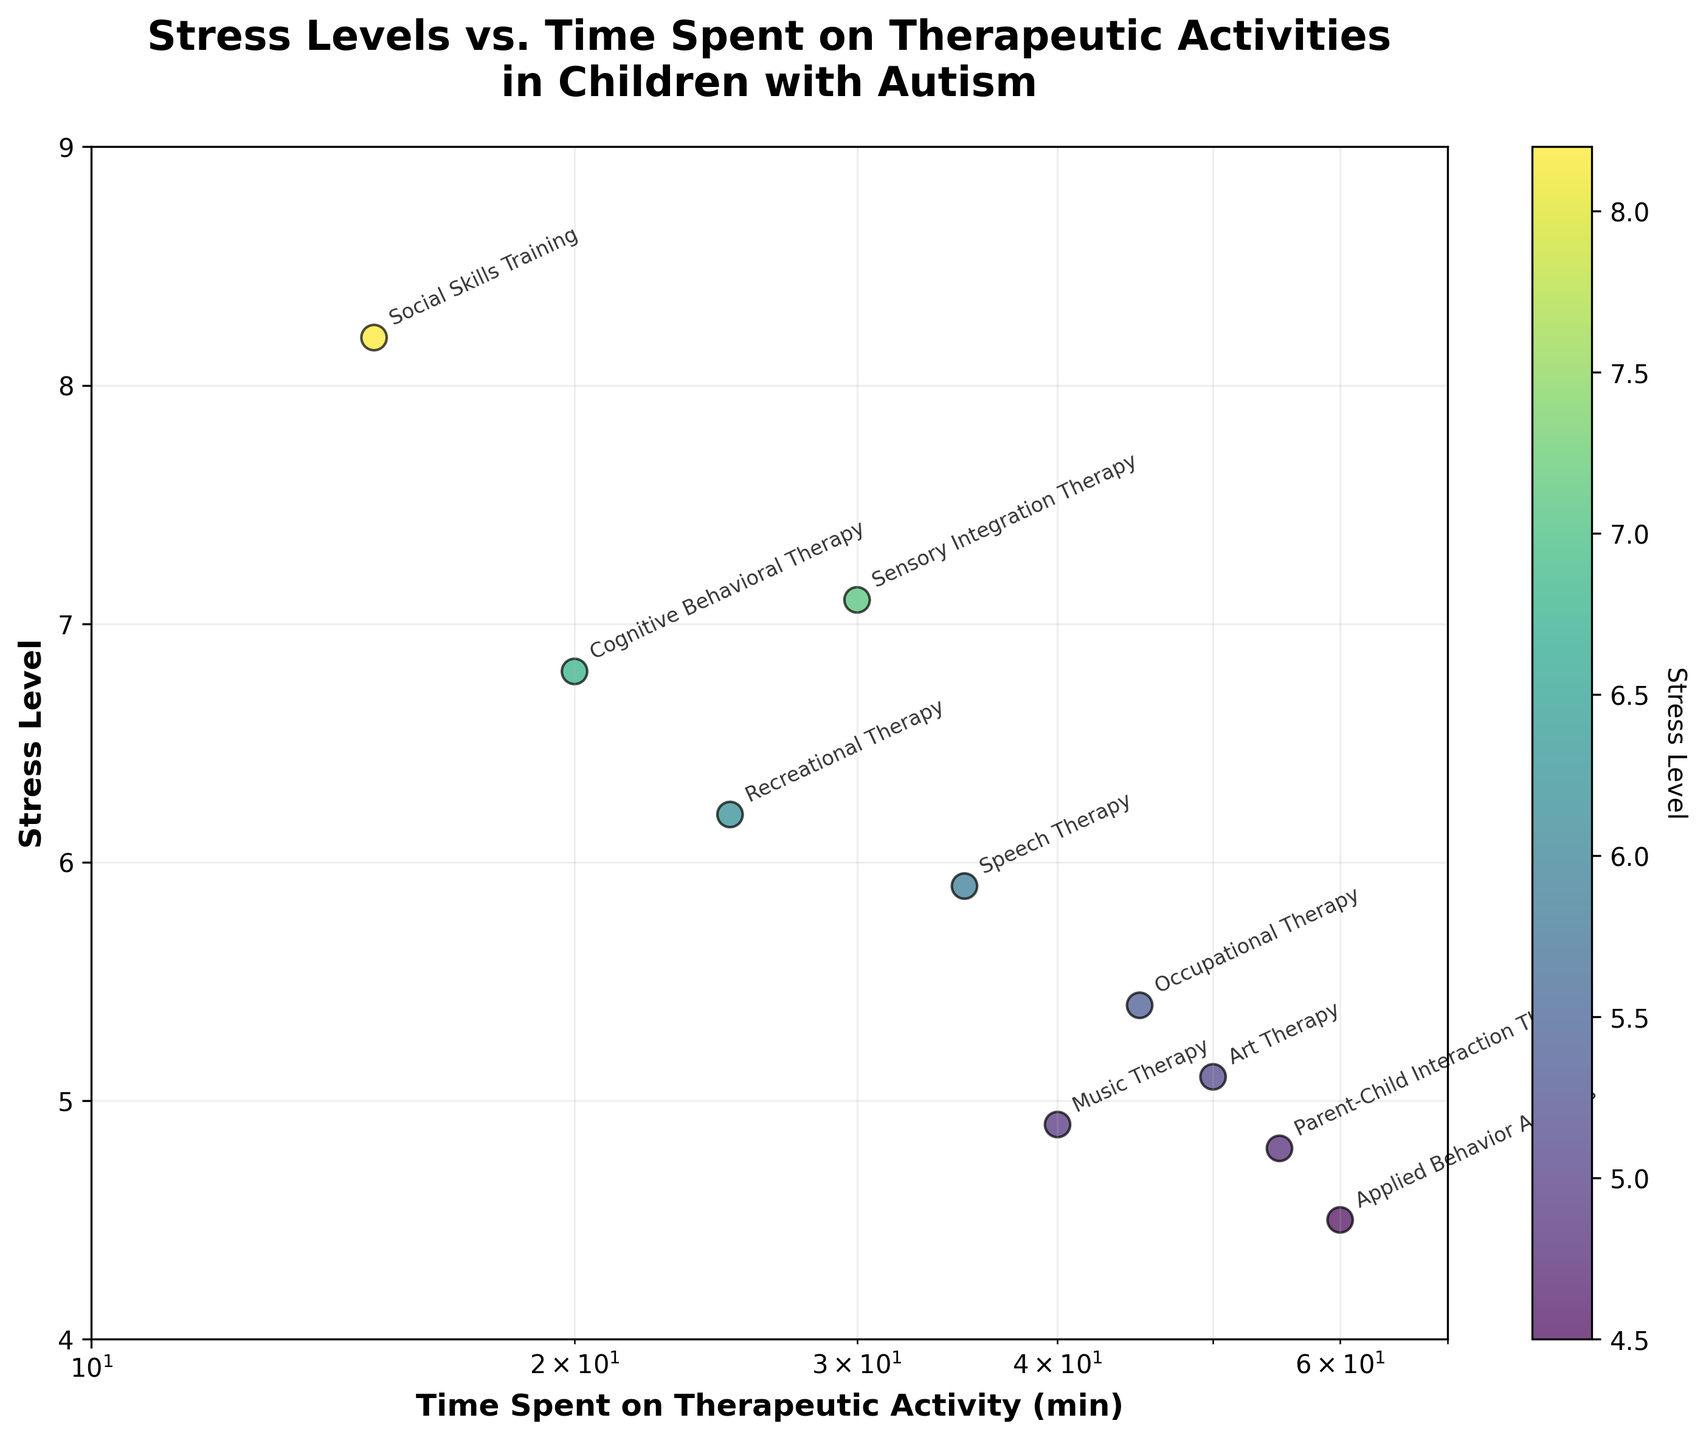What's the range of the y-axis? The y-axis represents the stress level and ranges from 4 to 9 as indicated on the y-axis labels.
Answer: 4 to 9 What's the therapeutic activity associated with the highest stress level? The scatter point at the highest position on the y-axis corresponds to Social Skills Training with a stress level of 8.2.
Answer: Social Skills Training How much time is spent on Occupational Therapy? The scatter point labeled Occupantional Therapy is located at 45 minutes on the x-axis.
Answer: 45 minutes Which therapeutic activity corresponds to the lowest stress level? The lowest position on the y-axis corresponds to Applied Behavior Analysis with a stress level of 4.5.
Answer: Applied Behavior Analysis What is the relationship observed between time spent on therapeutic activities and stress levels? Generally, as the time spent on therapeutic activities increases, the stress levels tend to decrease, indicated by the descending trend of the points from left to right.
Answer: Inverse relationship What's the average stress level of all therapeutic activities shown? Summing the stress levels: (8.2 + 7.1 + 5.4 + 6.8 + 5.9 + 6.2 + 4.5 + 4.9 + 5.1 + 4.8) = 58.9. Dividing by the number of activities (10): 58.9 / 10 = 5.89.
Answer: 5.89 Which activities have a stress level below 5? Identifying the activities with stress levels below 5: Applied Behavior Analysis (4.5), Music Therapy (4.9), Parent-Child Interaction Therapy (4.8).
Answer: Applied Behavior Analysis, Music Therapy, Parent-Child Interaction Therapy What's the difference in stress levels between Social Skills Training and Applied Behavior Analysis? Subtracting the stress level of Applied Behavior Analysis (4.5) from Social Skills Training (8.2): 8.2 - 4.5 = 3.7.
Answer: 3.7 How does stress level change when time spent increases from 15 minutes to 60 minutes? Observing the stress levels: 8.2 at 15 minutes (Social Skills Training) and 4.5 at 60 minutes (Applied Behavior Analysis), there is a decrease in stress level.
Answer: Decreases What is the median stress level for the given data points? Ordering the stress levels: (4.5, 4.8, 4.9, 5.1, 5.4, 5.9, 6.2, 6.8, 7.1, 8.2), the middle values are 5.4 and 5.9. The median is (5.4 + 5.9) / 2 = 5.65.
Answer: 5.65 